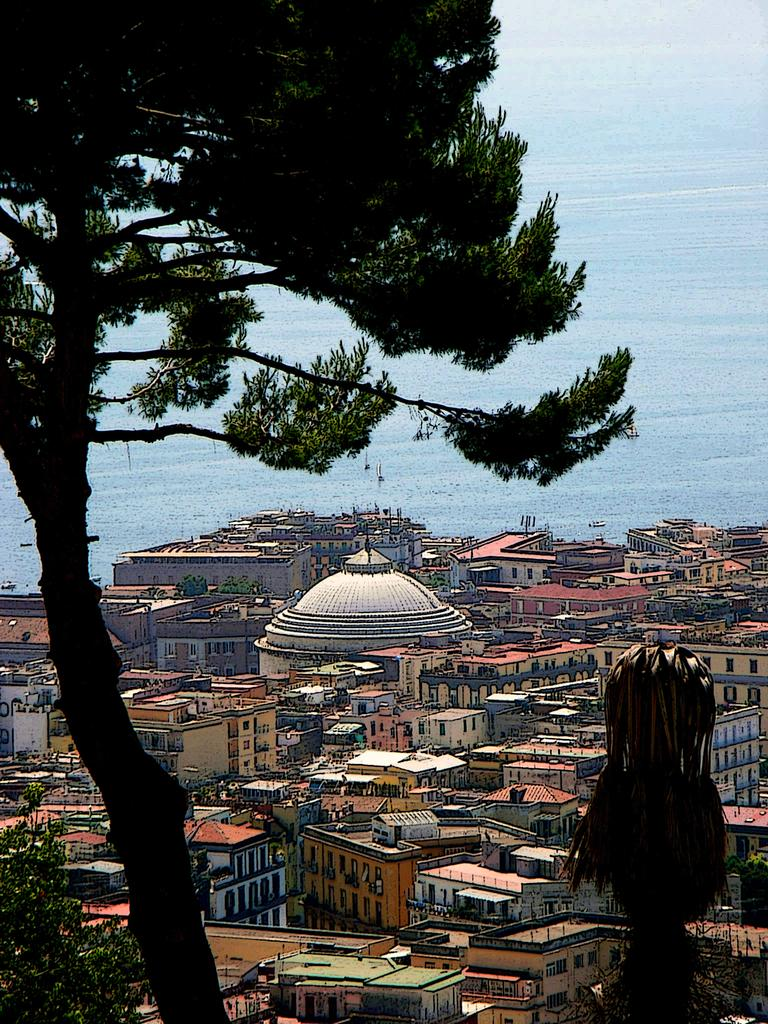What type of vegetation is on the left side of the image? There is a tree on the left side of the image. What can be seen on the right side of the image? There appears to be a plant on the right side of the image. What type of structures are visible in the background of the image? There are buildings in the background of the image. What specific architectural feature can be seen in the background? There is a dome visible in the background of the image. What natural element is visible in the background of the image? There is water in the background of the image. What is visible above the buildings and water in the image? The sky is visible in the background of the image. What is the opinion of the tree on the right side of the image? There is no opinion present in the image, as trees do not have the ability to express opinions. How many turkeys can be seen in the image? There are no turkeys present in the image. 